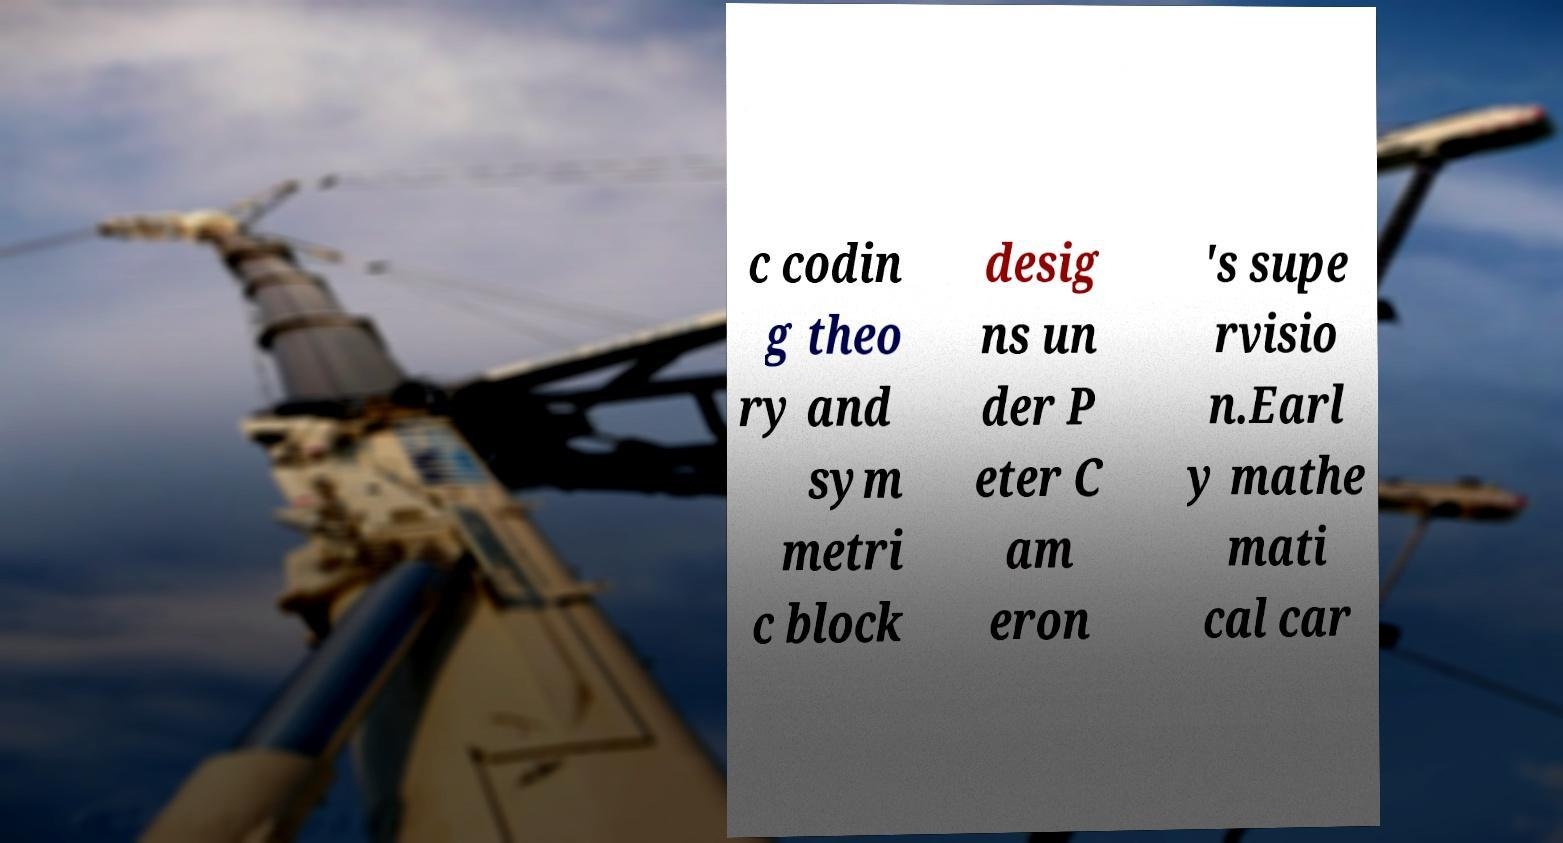I need the written content from this picture converted into text. Can you do that? c codin g theo ry and sym metri c block desig ns un der P eter C am eron 's supe rvisio n.Earl y mathe mati cal car 